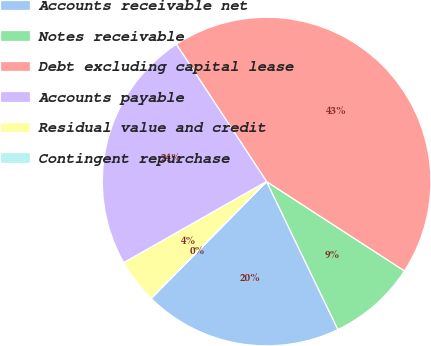Convert chart. <chart><loc_0><loc_0><loc_500><loc_500><pie_chart><fcel>Accounts receivable net<fcel>Notes receivable<fcel>Debt excluding capital lease<fcel>Accounts payable<fcel>Residual value and credit<fcel>Contingent repurchase<nl><fcel>19.54%<fcel>8.7%<fcel>43.4%<fcel>23.97%<fcel>4.36%<fcel>0.02%<nl></chart> 